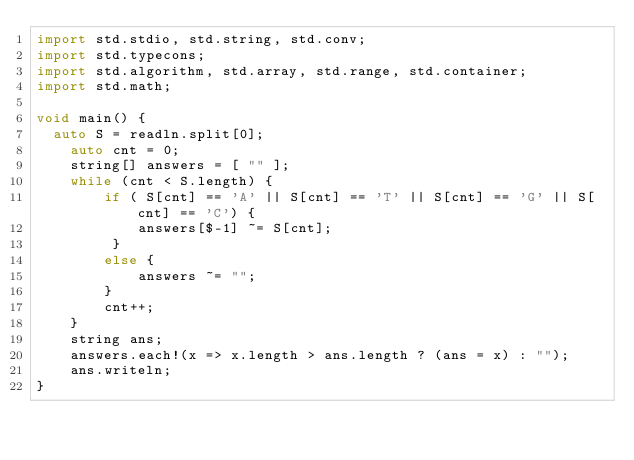Convert code to text. <code><loc_0><loc_0><loc_500><loc_500><_D_>import std.stdio, std.string, std.conv;
import std.typecons;
import std.algorithm, std.array, std.range, std.container;
import std.math;

void main() {
	auto S = readln.split[0];
    auto cnt = 0;
    string[] answers = [ "" ];
    while (cnt < S.length) {
        if ( S[cnt] == 'A' || S[cnt] == 'T' || S[cnt] == 'G' || S[cnt] == 'C') {
            answers[$-1] ~= S[cnt];
         }
        else {
            answers ~= "";
        }
        cnt++;
    }
    string ans;
    answers.each!(x => x.length > ans.length ? (ans = x) : "");
    ans.writeln;
}
</code> 